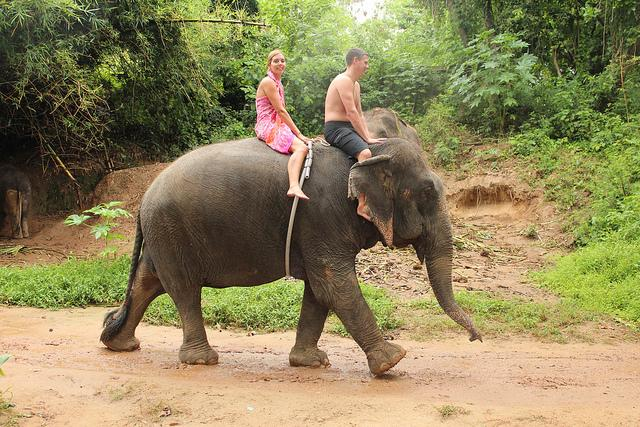What is the slowest thing that can move faster than the large thing here?

Choices:
A) airplane
B) car
C) ant
D) horse horse 